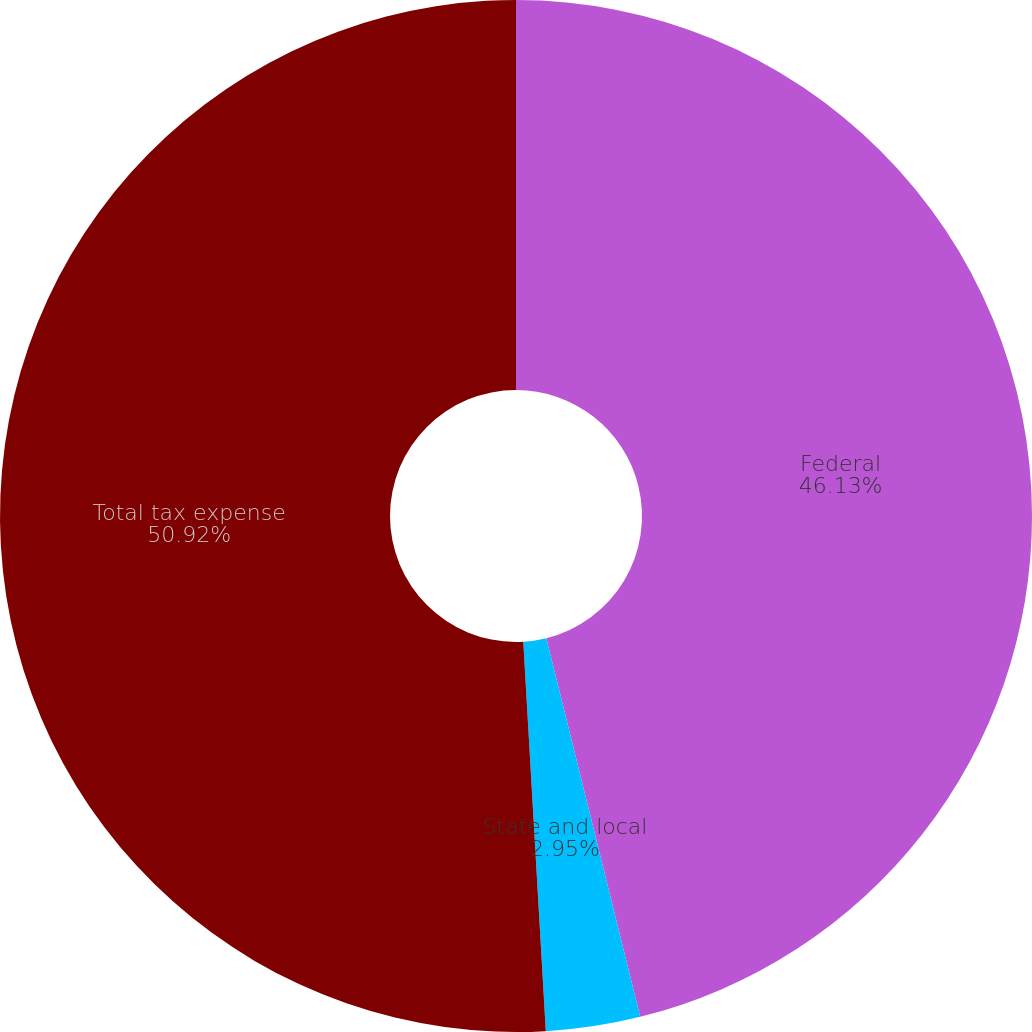Convert chart to OTSL. <chart><loc_0><loc_0><loc_500><loc_500><pie_chart><fcel>Federal<fcel>State and local<fcel>Total tax expense<nl><fcel>46.13%<fcel>2.95%<fcel>50.92%<nl></chart> 